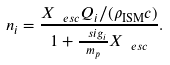Convert formula to latex. <formula><loc_0><loc_0><loc_500><loc_500>n _ { i } = \frac { X _ { \ e s c } Q _ { i } / ( \rho _ { \text {ISM} } c ) } { 1 + \frac { \ s i g _ { i } } { m _ { p } } X _ { \ e s c } } .</formula> 